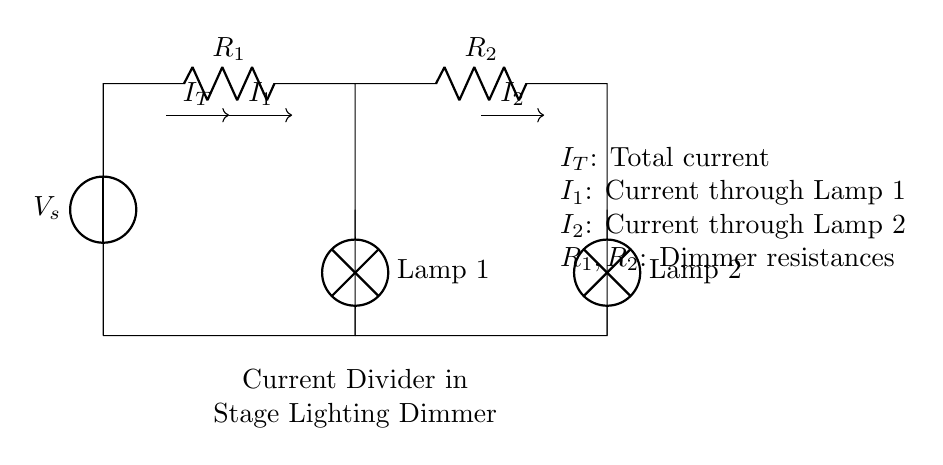What are the components in this circuit? The circuit contains a voltage source, two resistors, and two lamps. These are all connected in a way that allows for a current divider effect.
Answer: voltage source, resistors, lamps What is the total current entering the circuit? The total current, denoted as I_T, is the current that flows from the voltage source into the circuit before it splits into I_1 and I_2 through the two parallel branches.
Answer: I_T Which lamp receives more current? The lamp receiving more current correlates to the resistor with lower resistance. To determine the answer, we would typically compare R_1 and R_2. In this case, if R_1 < R_2, then Lamp 1 will receive more current.
Answer: Lamp 1 or Lamp 2 (depends on resistances) What formula relates the currents in a current divider? The formula used in a current divider is I_1 = I_T * (R_total / R_1) where R_total is the total resistance in the current branch configuration.
Answer: I_1 = I_T * (R_total / R_1) How do the resistances affect the current division? The current divides inversely with the resistances: a lower resistance will draw more current. Therefore, if R_1 is less than R_2, I_1 will be greater than I_2, demonstrating that the current is divided according to resistance values.
Answer: Inversely related What happens if one lamp fails? If one lamp fails, it acts like an open circuit and will stop the current flow through that branch. The total current will then flow only through the functioning branch, altering the division characteristics significantly.
Answer: Stops current in that branch 